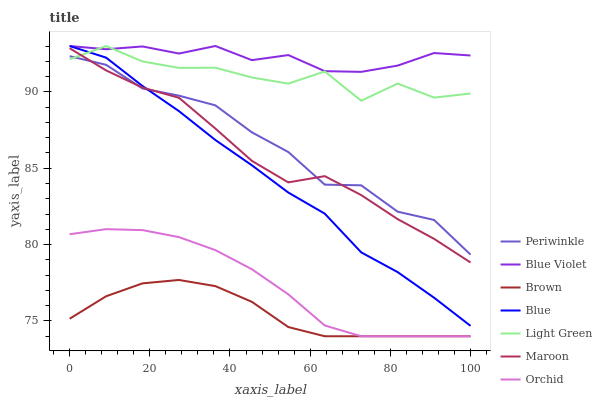Does Brown have the minimum area under the curve?
Answer yes or no. Yes. Does Blue Violet have the maximum area under the curve?
Answer yes or no. Yes. Does Maroon have the minimum area under the curve?
Answer yes or no. No. Does Maroon have the maximum area under the curve?
Answer yes or no. No. Is Orchid the smoothest?
Answer yes or no. Yes. Is Light Green the roughest?
Answer yes or no. Yes. Is Brown the smoothest?
Answer yes or no. No. Is Brown the roughest?
Answer yes or no. No. Does Brown have the lowest value?
Answer yes or no. Yes. Does Maroon have the lowest value?
Answer yes or no. No. Does Blue Violet have the highest value?
Answer yes or no. Yes. Does Maroon have the highest value?
Answer yes or no. No. Is Brown less than Maroon?
Answer yes or no. Yes. Is Blue Violet greater than Maroon?
Answer yes or no. Yes. Does Light Green intersect Periwinkle?
Answer yes or no. Yes. Is Light Green less than Periwinkle?
Answer yes or no. No. Is Light Green greater than Periwinkle?
Answer yes or no. No. Does Brown intersect Maroon?
Answer yes or no. No. 